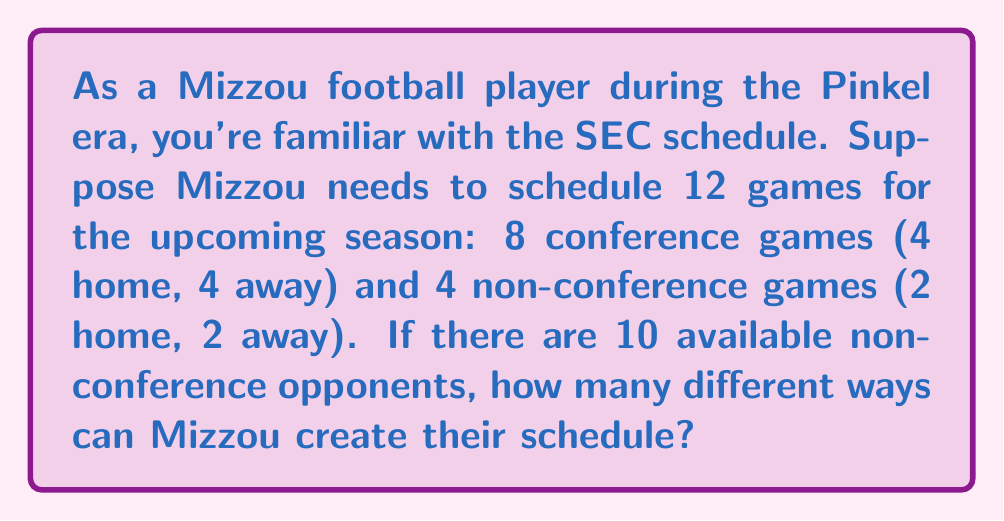Can you solve this math problem? Let's break this down step-by-step:

1) First, let's consider the conference games. These are predetermined by the SEC, so there's only 1 way to arrange them.

2) Now, for the non-conference games:
   - We need to choose 4 opponents out of 10 available teams.
   - This can be done in $\binom{10}{4}$ ways.

3) Calculate $\binom{10}{4}$:
   $$\binom{10}{4} = \frac{10!}{4!(10-4)!} = \frac{10!}{4!6!} = 210$$

4) Out of these 4 chosen teams, we need to decide which 2 will be home games and which 2 will be away games.
   - This is equivalent to choosing 2 teams out of 4 for home games (the other 2 will automatically be away games).
   - This can be done in $\binom{4}{2}$ ways.

5) Calculate $\binom{4}{2}$:
   $$\binom{4}{2} = \frac{4!}{2!(4-2)!} = \frac{4!}{2!2!} = 6$$

6) By the multiplication principle, the total number of ways to create the schedule is:
   $$1 \times 210 \times 6 = 1260$$

Therefore, there are 1260 different ways Mizzou can create their schedule.
Answer: 1260 